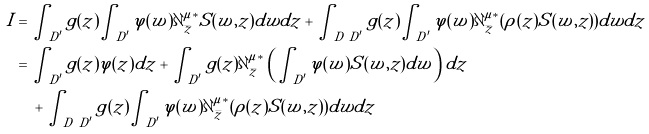<formula> <loc_0><loc_0><loc_500><loc_500>I & = \int _ { D ^ { \prime } } g ( z ) \int _ { D ^ { \prime } } \varphi ( w ) \partial _ { \bar { z } } ^ { \mu * } S ( w , z ) d w d z + \int _ { D \ D ^ { \prime } } g ( z ) \int _ { D ^ { \prime } } \varphi ( w ) \partial _ { \bar { z } } ^ { \mu * } ( \rho ( z ) S ( w , z ) ) d w d z \\ & = \int _ { D ^ { \prime } } g ( z ) \varphi ( z ) d z + \int _ { D ^ { \prime } } g ( z ) \partial _ { \bar { z } } ^ { \mu * } \left ( \int _ { D ^ { \prime } } \varphi ( w ) S ( w , z ) d w \right ) d z \\ & \text {\quad } + \int _ { D \ D ^ { \prime } } g ( z ) \int _ { D ^ { \prime } } \varphi ( w ) \partial _ { \bar { z } } ^ { \mu * } ( \rho ( z ) S ( w , z ) ) d w d z</formula> 